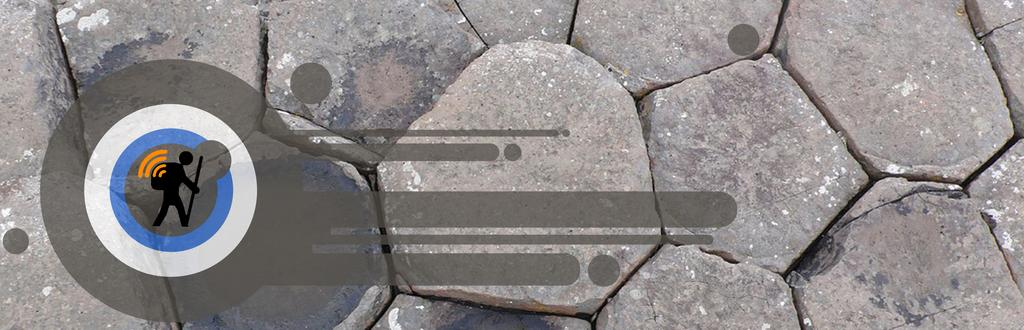What is the color of the surface in the image? The surface in the image is ash, white, and black in color. What type of art is present in the image? There is a digital art of a person in the image. What is the color of the digital art? The digital art is black in color. What type of sugar is being used by the doctor in the image? There is no doctor or sugar present in the image; it features a digital art of a person on an ash, white, and black surface. 